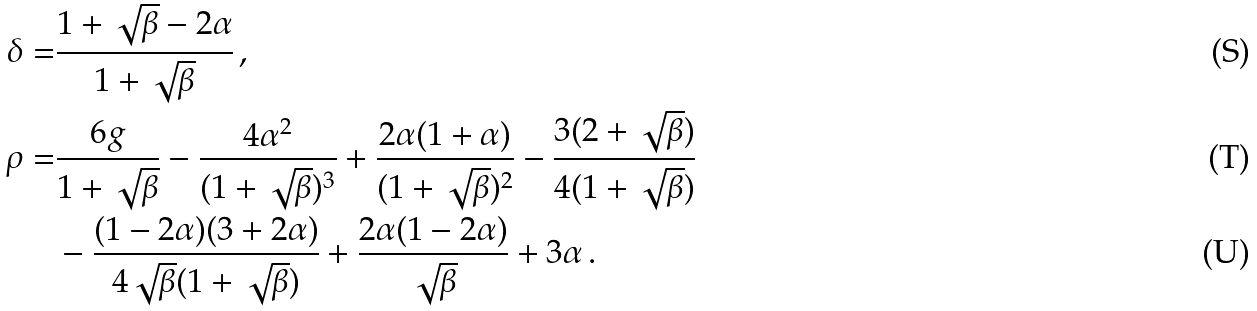Convert formula to latex. <formula><loc_0><loc_0><loc_500><loc_500>\delta = & \frac { 1 + \sqrt { \beta } - 2 \alpha } { 1 + \sqrt { \beta } } \, , \\ \rho = & \frac { 6 g } { 1 + \sqrt { \beta } } - \frac { 4 \alpha ^ { 2 } } { ( 1 + \sqrt { \beta } ) ^ { 3 } } + \frac { 2 \alpha ( 1 + \alpha ) } { ( 1 + \sqrt { \beta } ) ^ { 2 } } - \frac { 3 ( 2 + \sqrt { \beta } ) } { 4 ( 1 + \sqrt { \beta } ) } \\ & - \frac { ( 1 - 2 \alpha ) ( 3 + 2 \alpha ) } { 4 \sqrt { \beta } ( 1 + \sqrt { \beta } ) } + \frac { 2 \alpha ( 1 - 2 \alpha ) } { \sqrt { \beta } } + 3 \alpha \, .</formula> 